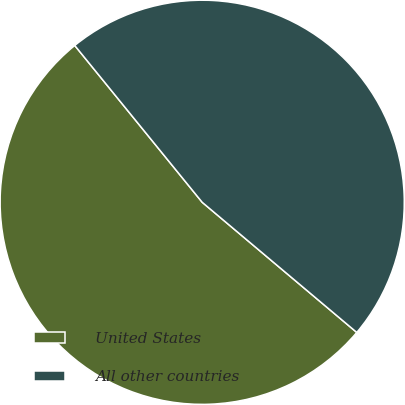Convert chart. <chart><loc_0><loc_0><loc_500><loc_500><pie_chart><fcel>United States<fcel>All other countries<nl><fcel>53.0%<fcel>47.0%<nl></chart> 